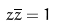Convert formula to latex. <formula><loc_0><loc_0><loc_500><loc_500>z \overline { z } = 1</formula> 